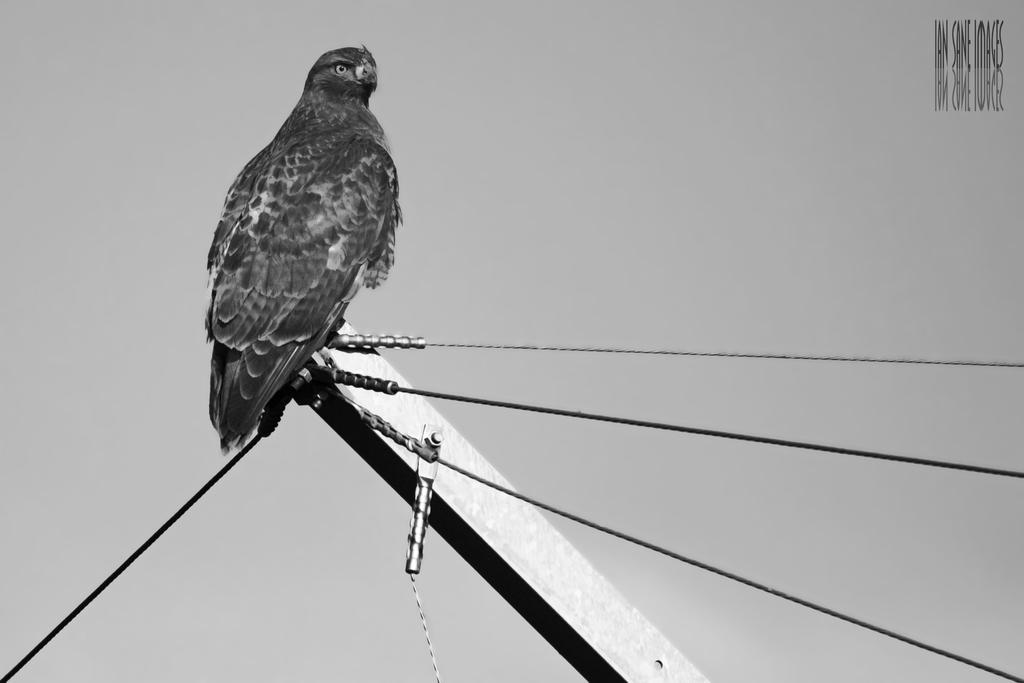What is the main object in the image? There is a pole in the image. What is the pole connected to? The pole is connected with wires. What animal can be seen on the pole? A bird is standing on the pole. What can be seen in the background of the image? The background of the image includes the sky. What type of shoes is the bird wearing in the image? There are no shoes present in the image, as birds do not wear shoes. Can you tell me how many chickens are visible in the image? There are no chickens present in the image; only a bird on the pole is visible. 